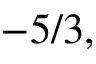<formula> <loc_0><loc_0><loc_500><loc_500>- 5 / 3 ,</formula> 